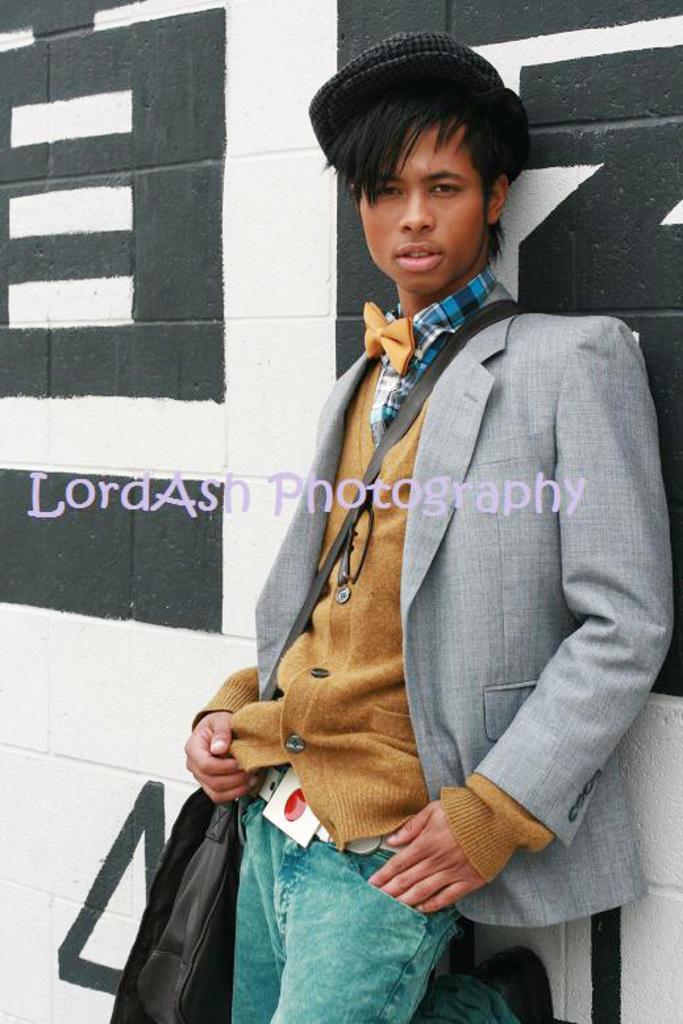How would you summarize this image in a sentence or two? In the image there is a man in yellow shirt and a grey suit over it and green jeans standing in front of wall. 